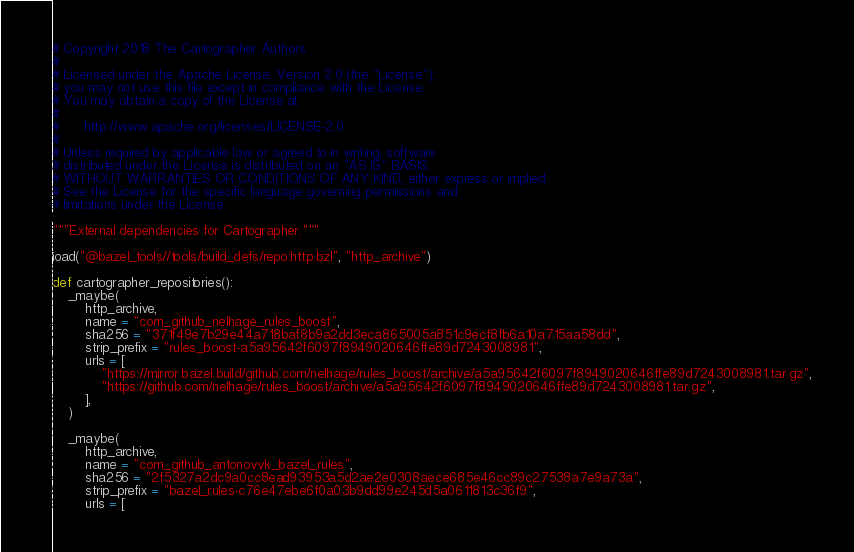<code> <loc_0><loc_0><loc_500><loc_500><_Python_># Copyright 2018 The Cartographer Authors
#
# Licensed under the Apache License, Version 2.0 (the "License");
# you may not use this file except in compliance with the License.
# You may obtain a copy of the License at
#
#      http://www.apache.org/licenses/LICENSE-2.0
#
# Unless required by applicable law or agreed to in writing, software
# distributed under the License is distributed on an "AS IS" BASIS,
# WITHOUT WARRANTIES OR CONDITIONS OF ANY KIND, either express or implied.
# See the License for the specific language governing permissions and
# limitations under the License.

"""External dependencies for Cartographer."""

load("@bazel_tools//tools/build_defs/repo:http.bzl", "http_archive")

def cartographer_repositories():
    _maybe(
        http_archive,
        name = "com_github_nelhage_rules_boost",
        sha256 = "371f49e7b29e44a718baf8b9a2dd3eca865005a851c9ecf8fb6a10a715aa58dd",
        strip_prefix = "rules_boost-a5a95642f6097f8949020646ffe89d7243008981",
        urls = [
            "https://mirror.bazel.build/github.com/nelhage/rules_boost/archive/a5a95642f6097f8949020646ffe89d7243008981.tar.gz",
            "https://github.com/nelhage/rules_boost/archive/a5a95642f6097f8949020646ffe89d7243008981.tar.gz",
        ],
    )

    _maybe(
        http_archive,
        name = "com_github_antonovvk_bazel_rules",
        sha256 = "2f5327a2dc9a0cc8ead93953a5d2ae2e0308aece685e46cc89c27538a7e9a73a",
        strip_prefix = "bazel_rules-c76e47ebe6f0a03b9dd99e245d5a0611813c36f9",
        urls = [</code> 